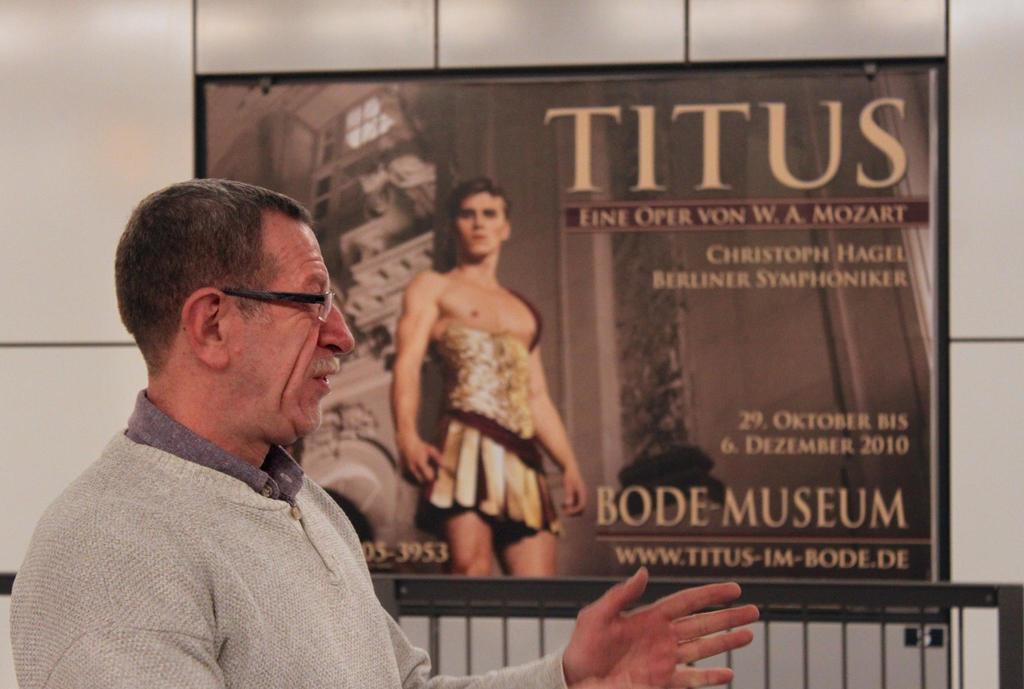Can you describe this image briefly? In this image there is one person who is talking, and in the background there is a board. On the board there is a depiction of one person and text, at the bottom of the image there are some grills and in the background there is wall. 